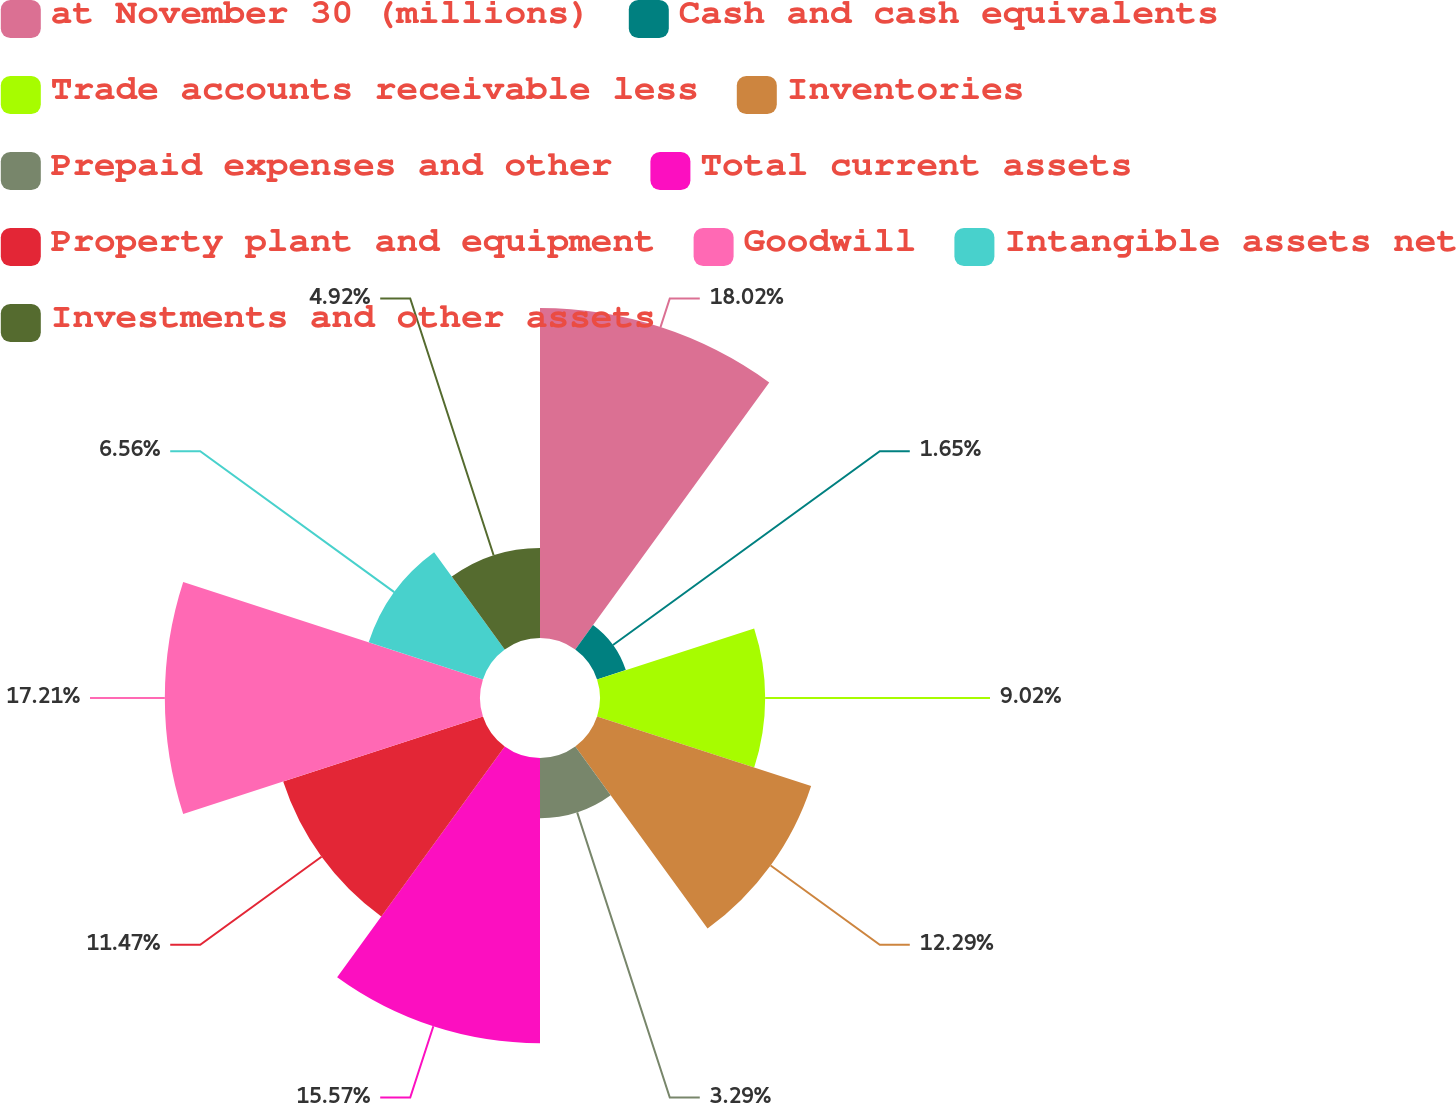<chart> <loc_0><loc_0><loc_500><loc_500><pie_chart><fcel>at November 30 (millions)<fcel>Cash and cash equivalents<fcel>Trade accounts receivable less<fcel>Inventories<fcel>Prepaid expenses and other<fcel>Total current assets<fcel>Property plant and equipment<fcel>Goodwill<fcel>Intangible assets net<fcel>Investments and other assets<nl><fcel>18.02%<fcel>1.65%<fcel>9.02%<fcel>12.29%<fcel>3.29%<fcel>15.57%<fcel>11.47%<fcel>17.21%<fcel>6.56%<fcel>4.92%<nl></chart> 